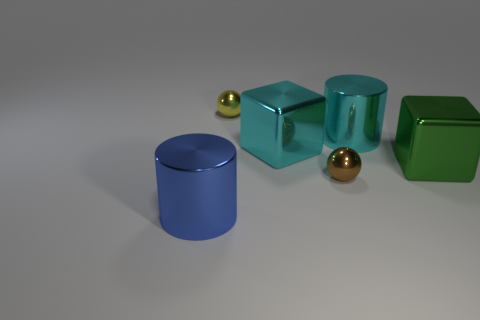What number of large yellow spheres are the same material as the large cyan cylinder?
Your answer should be very brief. 0. Is there a big green thing behind the small metal object that is in front of the small thing behind the brown sphere?
Your answer should be very brief. Yes. The large green thing that is made of the same material as the big blue cylinder is what shape?
Your answer should be compact. Cube. Are there more large cyan things than things?
Ensure brevity in your answer.  No. Do the brown object and the tiny metallic object that is behind the large cyan metal cylinder have the same shape?
Give a very brief answer. Yes. There is a metallic cylinder behind the tiny object that is to the right of the object that is behind the cyan metallic cylinder; what color is it?
Provide a succinct answer. Cyan. How many other metallic cylinders have the same size as the cyan cylinder?
Ensure brevity in your answer.  1. What number of tiny blue matte things are there?
Offer a very short reply. 0. How many red things are blocks or tiny metal things?
Your response must be concise. 0. The brown ball that is the same material as the big cyan cylinder is what size?
Your answer should be very brief. Small. 